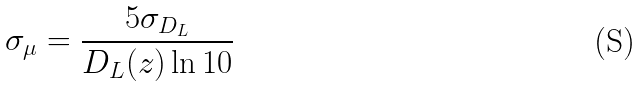Convert formula to latex. <formula><loc_0><loc_0><loc_500><loc_500>\sigma _ { \mu } = \frac { 5 \sigma _ { D _ { L } } } { D _ { L } ( z ) \ln { 1 0 } } \</formula> 